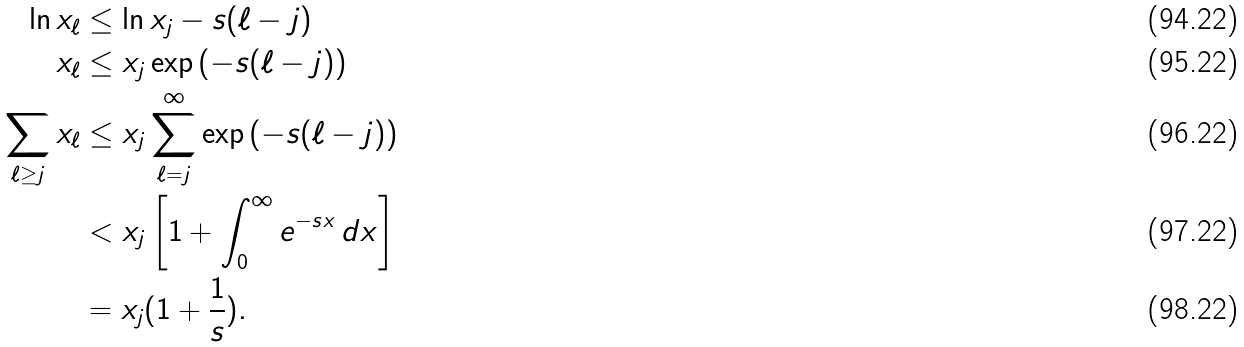<formula> <loc_0><loc_0><loc_500><loc_500>\ln x _ { \ell } & \leq \ln x _ { j } - s ( \ell - j ) \\ x _ { \ell } & \leq x _ { j } \exp \left ( - s ( \ell - j ) \right ) \\ \sum _ { \ell \geq j } x _ { \ell } & \leq x _ { j } \sum _ { \ell = j } ^ { \infty } \exp \left ( - s ( \ell - j ) \right ) \\ & < x _ { j } \left [ 1 + \int _ { 0 } ^ { \infty } e ^ { - s x } \, d x \right ] \\ & = x _ { j } ( 1 + \frac { 1 } { s } ) .</formula> 